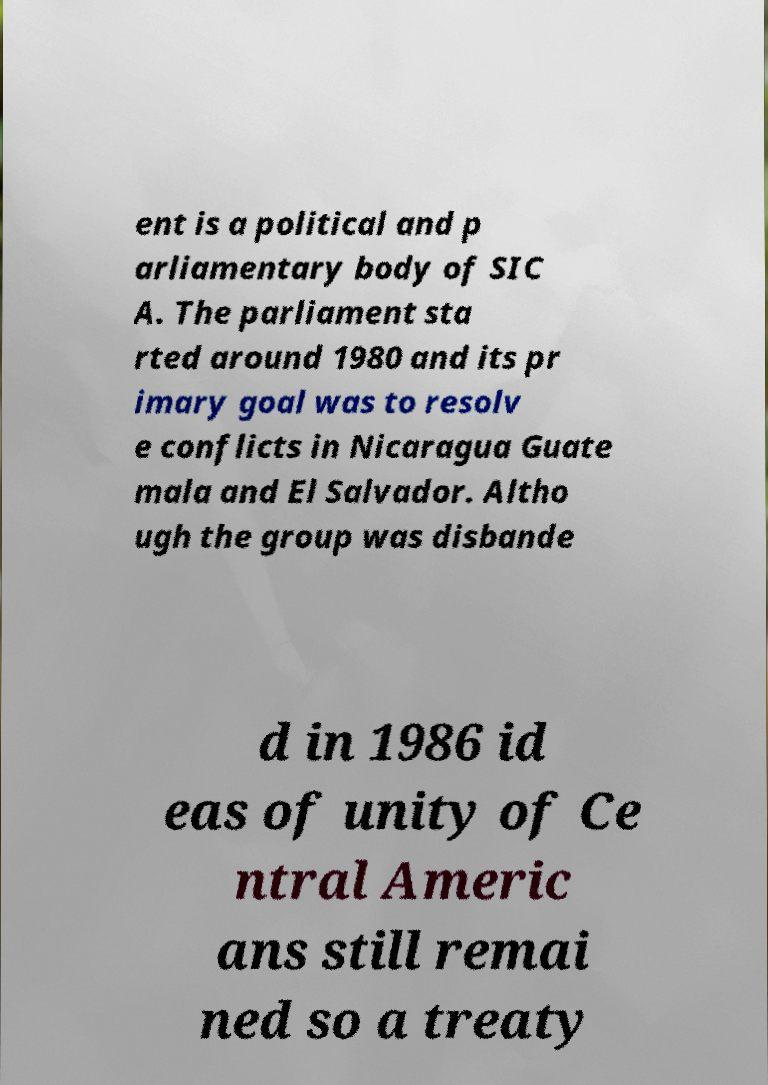Please read and relay the text visible in this image. What does it say? ent is a political and p arliamentary body of SIC A. The parliament sta rted around 1980 and its pr imary goal was to resolv e conflicts in Nicaragua Guate mala and El Salvador. Altho ugh the group was disbande d in 1986 id eas of unity of Ce ntral Americ ans still remai ned so a treaty 